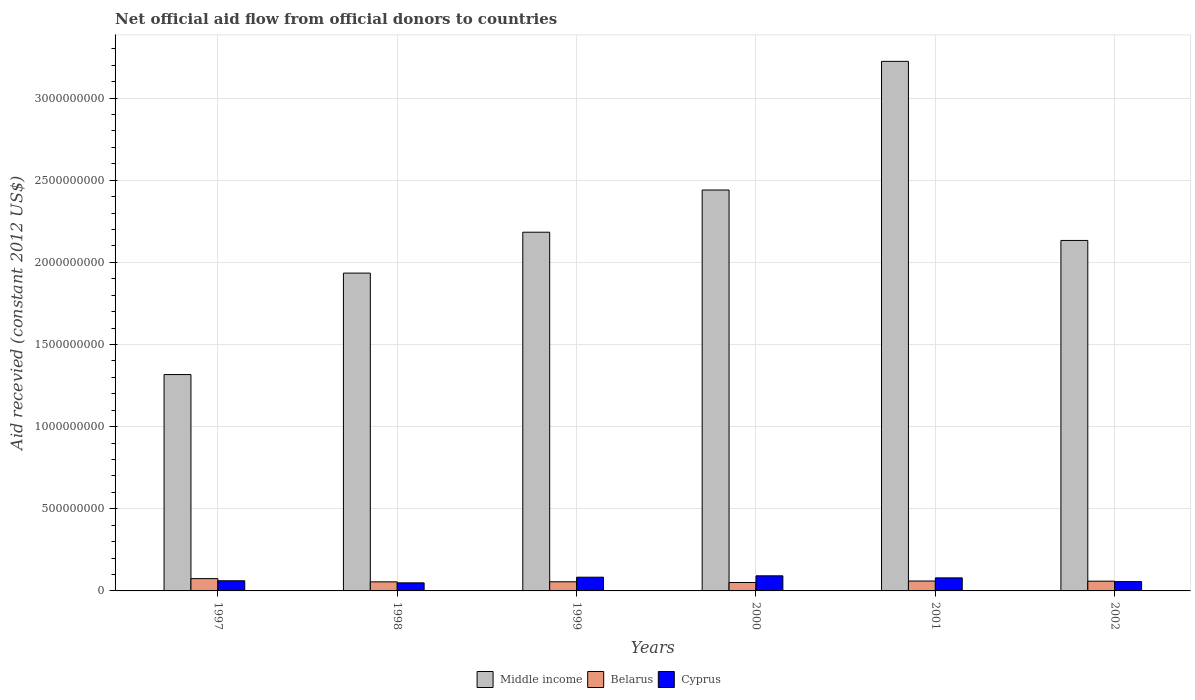How many different coloured bars are there?
Your response must be concise. 3. How many bars are there on the 6th tick from the right?
Your answer should be compact. 3. What is the label of the 1st group of bars from the left?
Offer a very short reply. 1997. What is the total aid received in Belarus in 2000?
Provide a succinct answer. 5.12e+07. Across all years, what is the maximum total aid received in Middle income?
Your response must be concise. 3.22e+09. Across all years, what is the minimum total aid received in Cyprus?
Offer a terse response. 4.91e+07. In which year was the total aid received in Cyprus minimum?
Offer a very short reply. 1998. What is the total total aid received in Cyprus in the graph?
Provide a short and direct response. 4.23e+08. What is the difference between the total aid received in Middle income in 2000 and that in 2001?
Ensure brevity in your answer.  -7.83e+08. What is the difference between the total aid received in Cyprus in 2000 and the total aid received in Belarus in 1998?
Make the answer very short. 3.67e+07. What is the average total aid received in Cyprus per year?
Ensure brevity in your answer.  7.04e+07. In the year 2001, what is the difference between the total aid received in Middle income and total aid received in Cyprus?
Your response must be concise. 3.14e+09. In how many years, is the total aid received in Middle income greater than 500000000 US$?
Give a very brief answer. 6. What is the ratio of the total aid received in Belarus in 2000 to that in 2002?
Offer a terse response. 0.86. What is the difference between the highest and the second highest total aid received in Cyprus?
Provide a short and direct response. 8.38e+06. What is the difference between the highest and the lowest total aid received in Belarus?
Offer a very short reply. 2.37e+07. In how many years, is the total aid received in Belarus greater than the average total aid received in Belarus taken over all years?
Your response must be concise. 2. What does the 3rd bar from the left in 1998 represents?
Your answer should be very brief. Cyprus. How many bars are there?
Your response must be concise. 18. Does the graph contain grids?
Your response must be concise. Yes. How are the legend labels stacked?
Your answer should be compact. Horizontal. What is the title of the graph?
Give a very brief answer. Net official aid flow from official donors to countries. What is the label or title of the X-axis?
Keep it short and to the point. Years. What is the label or title of the Y-axis?
Your answer should be compact. Aid recevied (constant 2012 US$). What is the Aid recevied (constant 2012 US$) in Middle income in 1997?
Your response must be concise. 1.32e+09. What is the Aid recevied (constant 2012 US$) of Belarus in 1997?
Offer a very short reply. 7.49e+07. What is the Aid recevied (constant 2012 US$) of Cyprus in 1997?
Your answer should be compact. 6.18e+07. What is the Aid recevied (constant 2012 US$) in Middle income in 1998?
Provide a short and direct response. 1.93e+09. What is the Aid recevied (constant 2012 US$) of Belarus in 1998?
Offer a very short reply. 5.52e+07. What is the Aid recevied (constant 2012 US$) of Cyprus in 1998?
Your answer should be compact. 4.91e+07. What is the Aid recevied (constant 2012 US$) of Middle income in 1999?
Your answer should be compact. 2.18e+09. What is the Aid recevied (constant 2012 US$) in Belarus in 1999?
Give a very brief answer. 5.57e+07. What is the Aid recevied (constant 2012 US$) in Cyprus in 1999?
Ensure brevity in your answer.  8.36e+07. What is the Aid recevied (constant 2012 US$) in Middle income in 2000?
Your response must be concise. 2.44e+09. What is the Aid recevied (constant 2012 US$) in Belarus in 2000?
Offer a very short reply. 5.12e+07. What is the Aid recevied (constant 2012 US$) of Cyprus in 2000?
Offer a terse response. 9.20e+07. What is the Aid recevied (constant 2012 US$) of Middle income in 2001?
Your response must be concise. 3.22e+09. What is the Aid recevied (constant 2012 US$) of Belarus in 2001?
Provide a succinct answer. 6.03e+07. What is the Aid recevied (constant 2012 US$) of Cyprus in 2001?
Give a very brief answer. 7.95e+07. What is the Aid recevied (constant 2012 US$) of Middle income in 2002?
Provide a succinct answer. 2.13e+09. What is the Aid recevied (constant 2012 US$) of Belarus in 2002?
Offer a very short reply. 5.93e+07. What is the Aid recevied (constant 2012 US$) in Cyprus in 2002?
Offer a terse response. 5.66e+07. Across all years, what is the maximum Aid recevied (constant 2012 US$) in Middle income?
Your answer should be compact. 3.22e+09. Across all years, what is the maximum Aid recevied (constant 2012 US$) of Belarus?
Offer a terse response. 7.49e+07. Across all years, what is the maximum Aid recevied (constant 2012 US$) of Cyprus?
Provide a short and direct response. 9.20e+07. Across all years, what is the minimum Aid recevied (constant 2012 US$) of Middle income?
Make the answer very short. 1.32e+09. Across all years, what is the minimum Aid recevied (constant 2012 US$) of Belarus?
Ensure brevity in your answer.  5.12e+07. Across all years, what is the minimum Aid recevied (constant 2012 US$) of Cyprus?
Offer a very short reply. 4.91e+07. What is the total Aid recevied (constant 2012 US$) in Middle income in the graph?
Your answer should be very brief. 1.32e+1. What is the total Aid recevied (constant 2012 US$) in Belarus in the graph?
Your answer should be very brief. 3.57e+08. What is the total Aid recevied (constant 2012 US$) of Cyprus in the graph?
Offer a terse response. 4.23e+08. What is the difference between the Aid recevied (constant 2012 US$) in Middle income in 1997 and that in 1998?
Your answer should be compact. -6.18e+08. What is the difference between the Aid recevied (constant 2012 US$) in Belarus in 1997 and that in 1998?
Your answer should be compact. 1.97e+07. What is the difference between the Aid recevied (constant 2012 US$) of Cyprus in 1997 and that in 1998?
Make the answer very short. 1.27e+07. What is the difference between the Aid recevied (constant 2012 US$) of Middle income in 1997 and that in 1999?
Offer a terse response. -8.67e+08. What is the difference between the Aid recevied (constant 2012 US$) in Belarus in 1997 and that in 1999?
Your answer should be compact. 1.92e+07. What is the difference between the Aid recevied (constant 2012 US$) in Cyprus in 1997 and that in 1999?
Give a very brief answer. -2.18e+07. What is the difference between the Aid recevied (constant 2012 US$) in Middle income in 1997 and that in 2000?
Your response must be concise. -1.12e+09. What is the difference between the Aid recevied (constant 2012 US$) in Belarus in 1997 and that in 2000?
Make the answer very short. 2.37e+07. What is the difference between the Aid recevied (constant 2012 US$) of Cyprus in 1997 and that in 2000?
Keep it short and to the point. -3.02e+07. What is the difference between the Aid recevied (constant 2012 US$) of Middle income in 1997 and that in 2001?
Offer a very short reply. -1.91e+09. What is the difference between the Aid recevied (constant 2012 US$) in Belarus in 1997 and that in 2001?
Give a very brief answer. 1.46e+07. What is the difference between the Aid recevied (constant 2012 US$) of Cyprus in 1997 and that in 2001?
Provide a succinct answer. -1.76e+07. What is the difference between the Aid recevied (constant 2012 US$) in Middle income in 1997 and that in 2002?
Offer a very short reply. -8.16e+08. What is the difference between the Aid recevied (constant 2012 US$) of Belarus in 1997 and that in 2002?
Provide a short and direct response. 1.56e+07. What is the difference between the Aid recevied (constant 2012 US$) in Cyprus in 1997 and that in 2002?
Your answer should be compact. 5.18e+06. What is the difference between the Aid recevied (constant 2012 US$) of Middle income in 1998 and that in 1999?
Ensure brevity in your answer.  -2.49e+08. What is the difference between the Aid recevied (constant 2012 US$) of Belarus in 1998 and that in 1999?
Make the answer very short. -4.70e+05. What is the difference between the Aid recevied (constant 2012 US$) in Cyprus in 1998 and that in 1999?
Your answer should be compact. -3.45e+07. What is the difference between the Aid recevied (constant 2012 US$) of Middle income in 1998 and that in 2000?
Give a very brief answer. -5.06e+08. What is the difference between the Aid recevied (constant 2012 US$) in Belarus in 1998 and that in 2000?
Keep it short and to the point. 3.99e+06. What is the difference between the Aid recevied (constant 2012 US$) of Cyprus in 1998 and that in 2000?
Give a very brief answer. -4.28e+07. What is the difference between the Aid recevied (constant 2012 US$) of Middle income in 1998 and that in 2001?
Make the answer very short. -1.29e+09. What is the difference between the Aid recevied (constant 2012 US$) in Belarus in 1998 and that in 2001?
Ensure brevity in your answer.  -5.05e+06. What is the difference between the Aid recevied (constant 2012 US$) of Cyprus in 1998 and that in 2001?
Provide a short and direct response. -3.03e+07. What is the difference between the Aid recevied (constant 2012 US$) in Middle income in 1998 and that in 2002?
Provide a short and direct response. -1.99e+08. What is the difference between the Aid recevied (constant 2012 US$) in Belarus in 1998 and that in 2002?
Offer a very short reply. -4.03e+06. What is the difference between the Aid recevied (constant 2012 US$) in Cyprus in 1998 and that in 2002?
Offer a terse response. -7.51e+06. What is the difference between the Aid recevied (constant 2012 US$) in Middle income in 1999 and that in 2000?
Offer a very short reply. -2.57e+08. What is the difference between the Aid recevied (constant 2012 US$) in Belarus in 1999 and that in 2000?
Your response must be concise. 4.46e+06. What is the difference between the Aid recevied (constant 2012 US$) of Cyprus in 1999 and that in 2000?
Offer a terse response. -8.38e+06. What is the difference between the Aid recevied (constant 2012 US$) of Middle income in 1999 and that in 2001?
Make the answer very short. -1.04e+09. What is the difference between the Aid recevied (constant 2012 US$) of Belarus in 1999 and that in 2001?
Offer a very short reply. -4.58e+06. What is the difference between the Aid recevied (constant 2012 US$) of Cyprus in 1999 and that in 2001?
Your answer should be compact. 4.13e+06. What is the difference between the Aid recevied (constant 2012 US$) in Middle income in 1999 and that in 2002?
Offer a terse response. 5.02e+07. What is the difference between the Aid recevied (constant 2012 US$) of Belarus in 1999 and that in 2002?
Keep it short and to the point. -3.56e+06. What is the difference between the Aid recevied (constant 2012 US$) of Cyprus in 1999 and that in 2002?
Keep it short and to the point. 2.70e+07. What is the difference between the Aid recevied (constant 2012 US$) in Middle income in 2000 and that in 2001?
Your response must be concise. -7.83e+08. What is the difference between the Aid recevied (constant 2012 US$) of Belarus in 2000 and that in 2001?
Ensure brevity in your answer.  -9.04e+06. What is the difference between the Aid recevied (constant 2012 US$) in Cyprus in 2000 and that in 2001?
Give a very brief answer. 1.25e+07. What is the difference between the Aid recevied (constant 2012 US$) in Middle income in 2000 and that in 2002?
Your response must be concise. 3.07e+08. What is the difference between the Aid recevied (constant 2012 US$) of Belarus in 2000 and that in 2002?
Keep it short and to the point. -8.02e+06. What is the difference between the Aid recevied (constant 2012 US$) in Cyprus in 2000 and that in 2002?
Make the answer very short. 3.53e+07. What is the difference between the Aid recevied (constant 2012 US$) in Middle income in 2001 and that in 2002?
Your answer should be compact. 1.09e+09. What is the difference between the Aid recevied (constant 2012 US$) in Belarus in 2001 and that in 2002?
Your answer should be very brief. 1.02e+06. What is the difference between the Aid recevied (constant 2012 US$) in Cyprus in 2001 and that in 2002?
Keep it short and to the point. 2.28e+07. What is the difference between the Aid recevied (constant 2012 US$) in Middle income in 1997 and the Aid recevied (constant 2012 US$) in Belarus in 1998?
Offer a terse response. 1.26e+09. What is the difference between the Aid recevied (constant 2012 US$) of Middle income in 1997 and the Aid recevied (constant 2012 US$) of Cyprus in 1998?
Your answer should be very brief. 1.27e+09. What is the difference between the Aid recevied (constant 2012 US$) in Belarus in 1997 and the Aid recevied (constant 2012 US$) in Cyprus in 1998?
Give a very brief answer. 2.58e+07. What is the difference between the Aid recevied (constant 2012 US$) in Middle income in 1997 and the Aid recevied (constant 2012 US$) in Belarus in 1999?
Your response must be concise. 1.26e+09. What is the difference between the Aid recevied (constant 2012 US$) of Middle income in 1997 and the Aid recevied (constant 2012 US$) of Cyprus in 1999?
Offer a very short reply. 1.23e+09. What is the difference between the Aid recevied (constant 2012 US$) of Belarus in 1997 and the Aid recevied (constant 2012 US$) of Cyprus in 1999?
Your response must be concise. -8.67e+06. What is the difference between the Aid recevied (constant 2012 US$) of Middle income in 1997 and the Aid recevied (constant 2012 US$) of Belarus in 2000?
Offer a very short reply. 1.27e+09. What is the difference between the Aid recevied (constant 2012 US$) of Middle income in 1997 and the Aid recevied (constant 2012 US$) of Cyprus in 2000?
Your answer should be very brief. 1.23e+09. What is the difference between the Aid recevied (constant 2012 US$) of Belarus in 1997 and the Aid recevied (constant 2012 US$) of Cyprus in 2000?
Provide a short and direct response. -1.70e+07. What is the difference between the Aid recevied (constant 2012 US$) in Middle income in 1997 and the Aid recevied (constant 2012 US$) in Belarus in 2001?
Give a very brief answer. 1.26e+09. What is the difference between the Aid recevied (constant 2012 US$) of Middle income in 1997 and the Aid recevied (constant 2012 US$) of Cyprus in 2001?
Give a very brief answer. 1.24e+09. What is the difference between the Aid recevied (constant 2012 US$) of Belarus in 1997 and the Aid recevied (constant 2012 US$) of Cyprus in 2001?
Provide a succinct answer. -4.54e+06. What is the difference between the Aid recevied (constant 2012 US$) of Middle income in 1997 and the Aid recevied (constant 2012 US$) of Belarus in 2002?
Keep it short and to the point. 1.26e+09. What is the difference between the Aid recevied (constant 2012 US$) of Middle income in 1997 and the Aid recevied (constant 2012 US$) of Cyprus in 2002?
Ensure brevity in your answer.  1.26e+09. What is the difference between the Aid recevied (constant 2012 US$) of Belarus in 1997 and the Aid recevied (constant 2012 US$) of Cyprus in 2002?
Provide a succinct answer. 1.83e+07. What is the difference between the Aid recevied (constant 2012 US$) in Middle income in 1998 and the Aid recevied (constant 2012 US$) in Belarus in 1999?
Make the answer very short. 1.88e+09. What is the difference between the Aid recevied (constant 2012 US$) of Middle income in 1998 and the Aid recevied (constant 2012 US$) of Cyprus in 1999?
Keep it short and to the point. 1.85e+09. What is the difference between the Aid recevied (constant 2012 US$) in Belarus in 1998 and the Aid recevied (constant 2012 US$) in Cyprus in 1999?
Provide a succinct answer. -2.84e+07. What is the difference between the Aid recevied (constant 2012 US$) in Middle income in 1998 and the Aid recevied (constant 2012 US$) in Belarus in 2000?
Ensure brevity in your answer.  1.88e+09. What is the difference between the Aid recevied (constant 2012 US$) of Middle income in 1998 and the Aid recevied (constant 2012 US$) of Cyprus in 2000?
Make the answer very short. 1.84e+09. What is the difference between the Aid recevied (constant 2012 US$) in Belarus in 1998 and the Aid recevied (constant 2012 US$) in Cyprus in 2000?
Your answer should be very brief. -3.67e+07. What is the difference between the Aid recevied (constant 2012 US$) of Middle income in 1998 and the Aid recevied (constant 2012 US$) of Belarus in 2001?
Make the answer very short. 1.87e+09. What is the difference between the Aid recevied (constant 2012 US$) of Middle income in 1998 and the Aid recevied (constant 2012 US$) of Cyprus in 2001?
Your answer should be compact. 1.86e+09. What is the difference between the Aid recevied (constant 2012 US$) in Belarus in 1998 and the Aid recevied (constant 2012 US$) in Cyprus in 2001?
Ensure brevity in your answer.  -2.42e+07. What is the difference between the Aid recevied (constant 2012 US$) of Middle income in 1998 and the Aid recevied (constant 2012 US$) of Belarus in 2002?
Give a very brief answer. 1.88e+09. What is the difference between the Aid recevied (constant 2012 US$) of Middle income in 1998 and the Aid recevied (constant 2012 US$) of Cyprus in 2002?
Offer a terse response. 1.88e+09. What is the difference between the Aid recevied (constant 2012 US$) in Belarus in 1998 and the Aid recevied (constant 2012 US$) in Cyprus in 2002?
Offer a very short reply. -1.39e+06. What is the difference between the Aid recevied (constant 2012 US$) of Middle income in 1999 and the Aid recevied (constant 2012 US$) of Belarus in 2000?
Ensure brevity in your answer.  2.13e+09. What is the difference between the Aid recevied (constant 2012 US$) in Middle income in 1999 and the Aid recevied (constant 2012 US$) in Cyprus in 2000?
Provide a succinct answer. 2.09e+09. What is the difference between the Aid recevied (constant 2012 US$) in Belarus in 1999 and the Aid recevied (constant 2012 US$) in Cyprus in 2000?
Your answer should be compact. -3.63e+07. What is the difference between the Aid recevied (constant 2012 US$) of Middle income in 1999 and the Aid recevied (constant 2012 US$) of Belarus in 2001?
Give a very brief answer. 2.12e+09. What is the difference between the Aid recevied (constant 2012 US$) of Middle income in 1999 and the Aid recevied (constant 2012 US$) of Cyprus in 2001?
Your response must be concise. 2.10e+09. What is the difference between the Aid recevied (constant 2012 US$) in Belarus in 1999 and the Aid recevied (constant 2012 US$) in Cyprus in 2001?
Give a very brief answer. -2.38e+07. What is the difference between the Aid recevied (constant 2012 US$) of Middle income in 1999 and the Aid recevied (constant 2012 US$) of Belarus in 2002?
Ensure brevity in your answer.  2.12e+09. What is the difference between the Aid recevied (constant 2012 US$) in Middle income in 1999 and the Aid recevied (constant 2012 US$) in Cyprus in 2002?
Make the answer very short. 2.13e+09. What is the difference between the Aid recevied (constant 2012 US$) of Belarus in 1999 and the Aid recevied (constant 2012 US$) of Cyprus in 2002?
Your response must be concise. -9.20e+05. What is the difference between the Aid recevied (constant 2012 US$) of Middle income in 2000 and the Aid recevied (constant 2012 US$) of Belarus in 2001?
Your answer should be very brief. 2.38e+09. What is the difference between the Aid recevied (constant 2012 US$) in Middle income in 2000 and the Aid recevied (constant 2012 US$) in Cyprus in 2001?
Keep it short and to the point. 2.36e+09. What is the difference between the Aid recevied (constant 2012 US$) in Belarus in 2000 and the Aid recevied (constant 2012 US$) in Cyprus in 2001?
Give a very brief answer. -2.82e+07. What is the difference between the Aid recevied (constant 2012 US$) in Middle income in 2000 and the Aid recevied (constant 2012 US$) in Belarus in 2002?
Give a very brief answer. 2.38e+09. What is the difference between the Aid recevied (constant 2012 US$) in Middle income in 2000 and the Aid recevied (constant 2012 US$) in Cyprus in 2002?
Provide a short and direct response. 2.38e+09. What is the difference between the Aid recevied (constant 2012 US$) of Belarus in 2000 and the Aid recevied (constant 2012 US$) of Cyprus in 2002?
Provide a short and direct response. -5.38e+06. What is the difference between the Aid recevied (constant 2012 US$) in Middle income in 2001 and the Aid recevied (constant 2012 US$) in Belarus in 2002?
Ensure brevity in your answer.  3.16e+09. What is the difference between the Aid recevied (constant 2012 US$) in Middle income in 2001 and the Aid recevied (constant 2012 US$) in Cyprus in 2002?
Your answer should be compact. 3.17e+09. What is the difference between the Aid recevied (constant 2012 US$) in Belarus in 2001 and the Aid recevied (constant 2012 US$) in Cyprus in 2002?
Ensure brevity in your answer.  3.66e+06. What is the average Aid recevied (constant 2012 US$) in Middle income per year?
Offer a very short reply. 2.21e+09. What is the average Aid recevied (constant 2012 US$) in Belarus per year?
Your response must be concise. 5.94e+07. What is the average Aid recevied (constant 2012 US$) in Cyprus per year?
Provide a short and direct response. 7.04e+07. In the year 1997, what is the difference between the Aid recevied (constant 2012 US$) in Middle income and Aid recevied (constant 2012 US$) in Belarus?
Provide a short and direct response. 1.24e+09. In the year 1997, what is the difference between the Aid recevied (constant 2012 US$) in Middle income and Aid recevied (constant 2012 US$) in Cyprus?
Your response must be concise. 1.26e+09. In the year 1997, what is the difference between the Aid recevied (constant 2012 US$) in Belarus and Aid recevied (constant 2012 US$) in Cyprus?
Give a very brief answer. 1.31e+07. In the year 1998, what is the difference between the Aid recevied (constant 2012 US$) of Middle income and Aid recevied (constant 2012 US$) of Belarus?
Your answer should be very brief. 1.88e+09. In the year 1998, what is the difference between the Aid recevied (constant 2012 US$) of Middle income and Aid recevied (constant 2012 US$) of Cyprus?
Provide a succinct answer. 1.89e+09. In the year 1998, what is the difference between the Aid recevied (constant 2012 US$) of Belarus and Aid recevied (constant 2012 US$) of Cyprus?
Provide a succinct answer. 6.12e+06. In the year 1999, what is the difference between the Aid recevied (constant 2012 US$) in Middle income and Aid recevied (constant 2012 US$) in Belarus?
Keep it short and to the point. 2.13e+09. In the year 1999, what is the difference between the Aid recevied (constant 2012 US$) of Middle income and Aid recevied (constant 2012 US$) of Cyprus?
Ensure brevity in your answer.  2.10e+09. In the year 1999, what is the difference between the Aid recevied (constant 2012 US$) of Belarus and Aid recevied (constant 2012 US$) of Cyprus?
Make the answer very short. -2.79e+07. In the year 2000, what is the difference between the Aid recevied (constant 2012 US$) in Middle income and Aid recevied (constant 2012 US$) in Belarus?
Give a very brief answer. 2.39e+09. In the year 2000, what is the difference between the Aid recevied (constant 2012 US$) of Middle income and Aid recevied (constant 2012 US$) of Cyprus?
Offer a terse response. 2.35e+09. In the year 2000, what is the difference between the Aid recevied (constant 2012 US$) of Belarus and Aid recevied (constant 2012 US$) of Cyprus?
Provide a short and direct response. -4.07e+07. In the year 2001, what is the difference between the Aid recevied (constant 2012 US$) of Middle income and Aid recevied (constant 2012 US$) of Belarus?
Provide a succinct answer. 3.16e+09. In the year 2001, what is the difference between the Aid recevied (constant 2012 US$) in Middle income and Aid recevied (constant 2012 US$) in Cyprus?
Ensure brevity in your answer.  3.14e+09. In the year 2001, what is the difference between the Aid recevied (constant 2012 US$) in Belarus and Aid recevied (constant 2012 US$) in Cyprus?
Keep it short and to the point. -1.92e+07. In the year 2002, what is the difference between the Aid recevied (constant 2012 US$) in Middle income and Aid recevied (constant 2012 US$) in Belarus?
Ensure brevity in your answer.  2.07e+09. In the year 2002, what is the difference between the Aid recevied (constant 2012 US$) in Middle income and Aid recevied (constant 2012 US$) in Cyprus?
Your answer should be compact. 2.08e+09. In the year 2002, what is the difference between the Aid recevied (constant 2012 US$) in Belarus and Aid recevied (constant 2012 US$) in Cyprus?
Give a very brief answer. 2.64e+06. What is the ratio of the Aid recevied (constant 2012 US$) in Middle income in 1997 to that in 1998?
Keep it short and to the point. 0.68. What is the ratio of the Aid recevied (constant 2012 US$) of Belarus in 1997 to that in 1998?
Your answer should be compact. 1.36. What is the ratio of the Aid recevied (constant 2012 US$) in Cyprus in 1997 to that in 1998?
Make the answer very short. 1.26. What is the ratio of the Aid recevied (constant 2012 US$) of Middle income in 1997 to that in 1999?
Your response must be concise. 0.6. What is the ratio of the Aid recevied (constant 2012 US$) in Belarus in 1997 to that in 1999?
Offer a terse response. 1.34. What is the ratio of the Aid recevied (constant 2012 US$) of Cyprus in 1997 to that in 1999?
Your response must be concise. 0.74. What is the ratio of the Aid recevied (constant 2012 US$) of Middle income in 1997 to that in 2000?
Offer a very short reply. 0.54. What is the ratio of the Aid recevied (constant 2012 US$) of Belarus in 1997 to that in 2000?
Your answer should be very brief. 1.46. What is the ratio of the Aid recevied (constant 2012 US$) in Cyprus in 1997 to that in 2000?
Ensure brevity in your answer.  0.67. What is the ratio of the Aid recevied (constant 2012 US$) in Middle income in 1997 to that in 2001?
Your response must be concise. 0.41. What is the ratio of the Aid recevied (constant 2012 US$) of Belarus in 1997 to that in 2001?
Your response must be concise. 1.24. What is the ratio of the Aid recevied (constant 2012 US$) of Cyprus in 1997 to that in 2001?
Keep it short and to the point. 0.78. What is the ratio of the Aid recevied (constant 2012 US$) of Middle income in 1997 to that in 2002?
Give a very brief answer. 0.62. What is the ratio of the Aid recevied (constant 2012 US$) in Belarus in 1997 to that in 2002?
Keep it short and to the point. 1.26. What is the ratio of the Aid recevied (constant 2012 US$) of Cyprus in 1997 to that in 2002?
Provide a short and direct response. 1.09. What is the ratio of the Aid recevied (constant 2012 US$) in Middle income in 1998 to that in 1999?
Offer a terse response. 0.89. What is the ratio of the Aid recevied (constant 2012 US$) in Cyprus in 1998 to that in 1999?
Your answer should be very brief. 0.59. What is the ratio of the Aid recevied (constant 2012 US$) in Middle income in 1998 to that in 2000?
Ensure brevity in your answer.  0.79. What is the ratio of the Aid recevied (constant 2012 US$) in Belarus in 1998 to that in 2000?
Provide a succinct answer. 1.08. What is the ratio of the Aid recevied (constant 2012 US$) in Cyprus in 1998 to that in 2000?
Keep it short and to the point. 0.53. What is the ratio of the Aid recevied (constant 2012 US$) of Middle income in 1998 to that in 2001?
Ensure brevity in your answer.  0.6. What is the ratio of the Aid recevied (constant 2012 US$) of Belarus in 1998 to that in 2001?
Provide a short and direct response. 0.92. What is the ratio of the Aid recevied (constant 2012 US$) in Cyprus in 1998 to that in 2001?
Give a very brief answer. 0.62. What is the ratio of the Aid recevied (constant 2012 US$) of Middle income in 1998 to that in 2002?
Give a very brief answer. 0.91. What is the ratio of the Aid recevied (constant 2012 US$) in Belarus in 1998 to that in 2002?
Give a very brief answer. 0.93. What is the ratio of the Aid recevied (constant 2012 US$) of Cyprus in 1998 to that in 2002?
Keep it short and to the point. 0.87. What is the ratio of the Aid recevied (constant 2012 US$) in Middle income in 1999 to that in 2000?
Provide a succinct answer. 0.89. What is the ratio of the Aid recevied (constant 2012 US$) of Belarus in 1999 to that in 2000?
Your answer should be compact. 1.09. What is the ratio of the Aid recevied (constant 2012 US$) in Cyprus in 1999 to that in 2000?
Offer a very short reply. 0.91. What is the ratio of the Aid recevied (constant 2012 US$) of Middle income in 1999 to that in 2001?
Give a very brief answer. 0.68. What is the ratio of the Aid recevied (constant 2012 US$) in Belarus in 1999 to that in 2001?
Offer a terse response. 0.92. What is the ratio of the Aid recevied (constant 2012 US$) of Cyprus in 1999 to that in 2001?
Keep it short and to the point. 1.05. What is the ratio of the Aid recevied (constant 2012 US$) of Middle income in 1999 to that in 2002?
Provide a short and direct response. 1.02. What is the ratio of the Aid recevied (constant 2012 US$) of Belarus in 1999 to that in 2002?
Offer a terse response. 0.94. What is the ratio of the Aid recevied (constant 2012 US$) of Cyprus in 1999 to that in 2002?
Your answer should be compact. 1.48. What is the ratio of the Aid recevied (constant 2012 US$) in Middle income in 2000 to that in 2001?
Provide a succinct answer. 0.76. What is the ratio of the Aid recevied (constant 2012 US$) of Belarus in 2000 to that in 2001?
Make the answer very short. 0.85. What is the ratio of the Aid recevied (constant 2012 US$) of Cyprus in 2000 to that in 2001?
Ensure brevity in your answer.  1.16. What is the ratio of the Aid recevied (constant 2012 US$) of Middle income in 2000 to that in 2002?
Ensure brevity in your answer.  1.14. What is the ratio of the Aid recevied (constant 2012 US$) in Belarus in 2000 to that in 2002?
Offer a very short reply. 0.86. What is the ratio of the Aid recevied (constant 2012 US$) in Cyprus in 2000 to that in 2002?
Make the answer very short. 1.62. What is the ratio of the Aid recevied (constant 2012 US$) of Middle income in 2001 to that in 2002?
Your answer should be compact. 1.51. What is the ratio of the Aid recevied (constant 2012 US$) of Belarus in 2001 to that in 2002?
Keep it short and to the point. 1.02. What is the ratio of the Aid recevied (constant 2012 US$) of Cyprus in 2001 to that in 2002?
Your answer should be compact. 1.4. What is the difference between the highest and the second highest Aid recevied (constant 2012 US$) of Middle income?
Make the answer very short. 7.83e+08. What is the difference between the highest and the second highest Aid recevied (constant 2012 US$) in Belarus?
Your answer should be very brief. 1.46e+07. What is the difference between the highest and the second highest Aid recevied (constant 2012 US$) of Cyprus?
Provide a succinct answer. 8.38e+06. What is the difference between the highest and the lowest Aid recevied (constant 2012 US$) of Middle income?
Keep it short and to the point. 1.91e+09. What is the difference between the highest and the lowest Aid recevied (constant 2012 US$) in Belarus?
Offer a very short reply. 2.37e+07. What is the difference between the highest and the lowest Aid recevied (constant 2012 US$) of Cyprus?
Make the answer very short. 4.28e+07. 